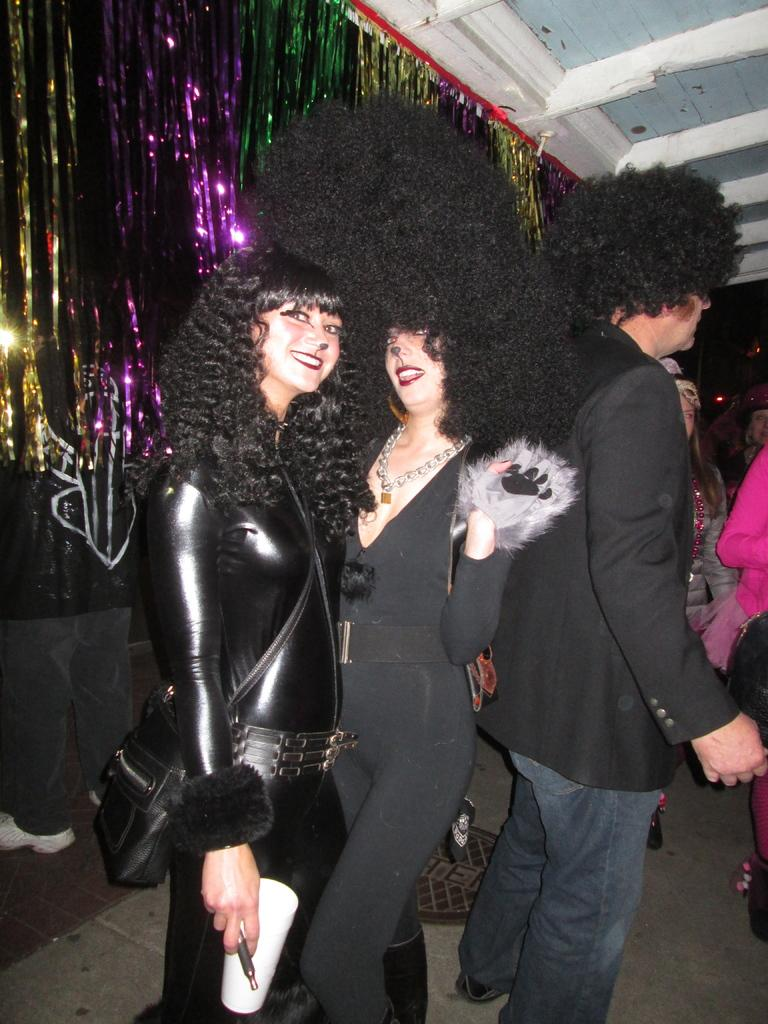How many women are present in the image? There are two women in the image. What is the facial expression of the women? The women are smiling. Can you describe the person behind the women? There is a person behind the women, but no specific details are provided. How many other women are standing behind the two women? There is at least one other woman standing behind the women. What type of magic is being performed by the women in the image? There is no indication of magic or any magical activity in the image. 